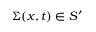<formula> <loc_0><loc_0><loc_500><loc_500>\Sigma ( x , t ) \in S ^ { \prime }</formula> 